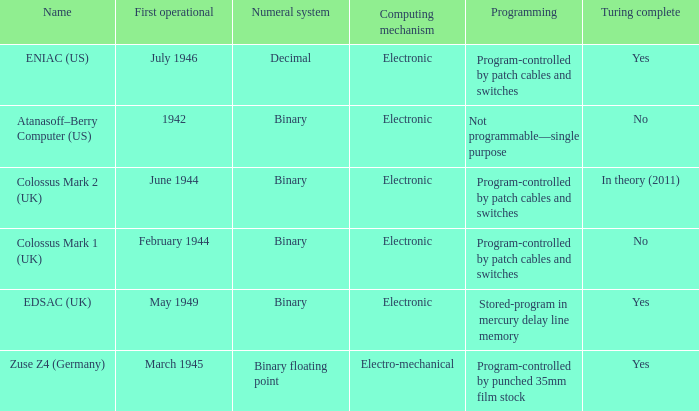What's the computing mechanbeingm with first operational being february 1944 Electronic. 